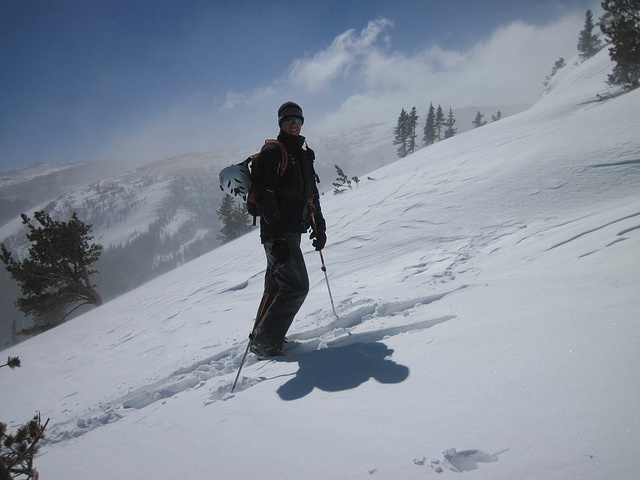Describe the objects in this image and their specific colors. I can see people in darkblue, black, gray, and darkgray tones and backpack in darkblue, black, gray, blue, and darkgray tones in this image. 